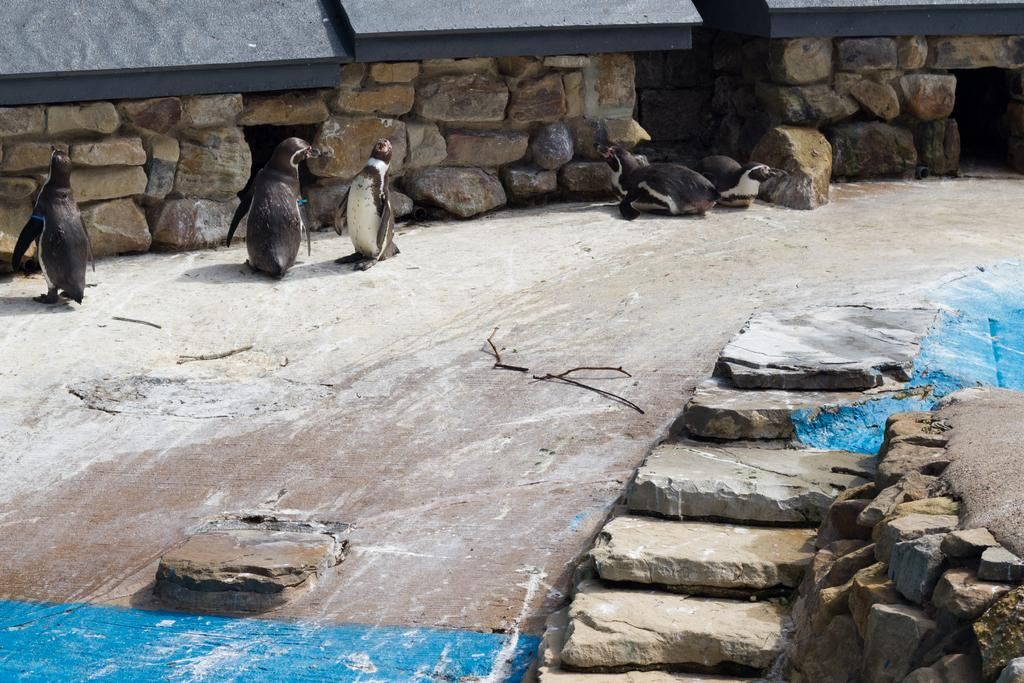What type of animals are in the image? There are penguins in the image. What else can be seen in the image besides the penguins? There are rocks in the image. What is visible in the background of the image? There is a rock wall in the background of the image. Can you see a crown on any of the penguins in the image? No, there is no crown present on any of the penguins in the image. 